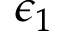<formula> <loc_0><loc_0><loc_500><loc_500>\epsilon _ { 1 }</formula> 